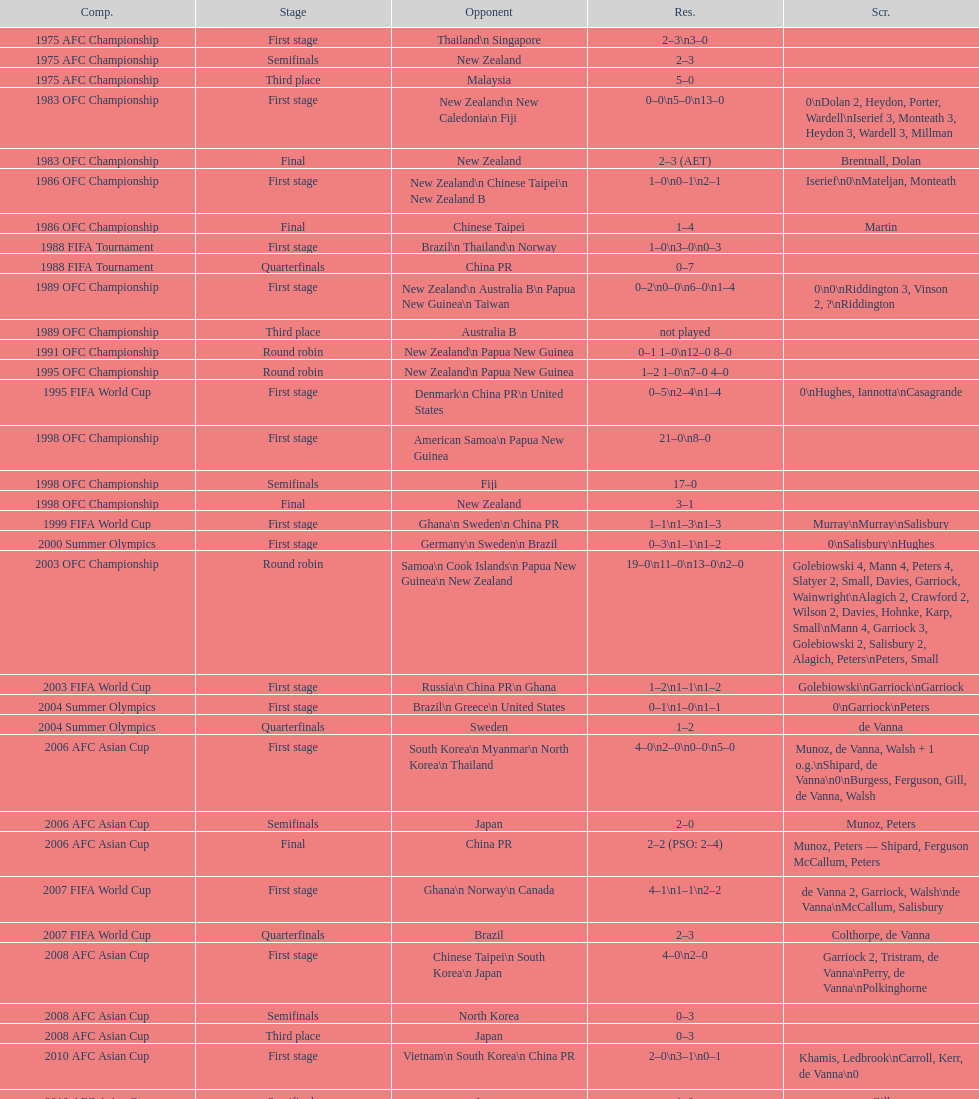How many stages were round robins? 3. 